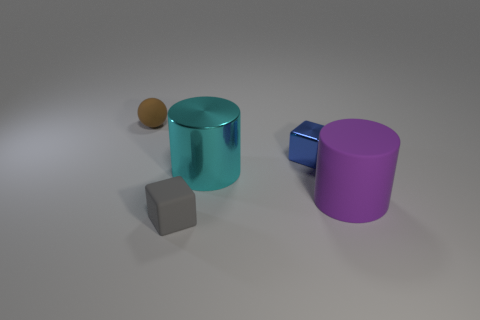Subtract all balls. How many objects are left? 4 Add 4 blue matte things. How many objects exist? 9 Subtract 2 cubes. How many cubes are left? 0 Subtract all large cyan metal blocks. Subtract all spheres. How many objects are left? 4 Add 4 brown matte objects. How many brown matte objects are left? 5 Add 5 tiny blue balls. How many tiny blue balls exist? 5 Subtract 0 red spheres. How many objects are left? 5 Subtract all red spheres. Subtract all purple cylinders. How many spheres are left? 1 Subtract all purple cylinders. How many gray cubes are left? 1 